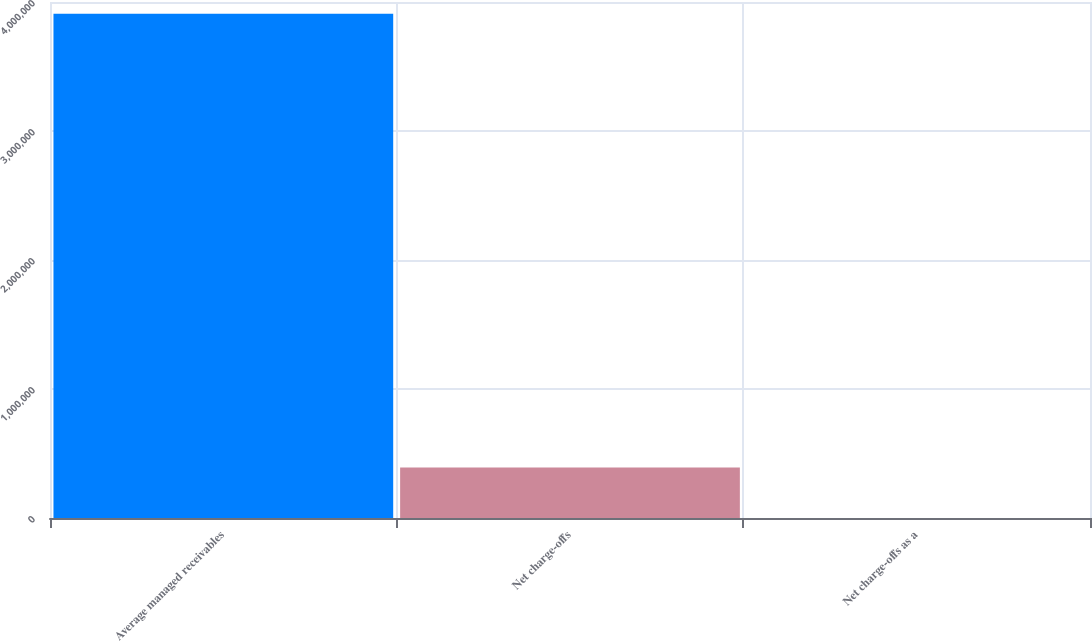<chart> <loc_0><loc_0><loc_500><loc_500><bar_chart><fcel>Average managed receivables<fcel>Net charge-offs<fcel>Net charge-offs as a<nl><fcel>3.90963e+06<fcel>390968<fcel>5.8<nl></chart> 